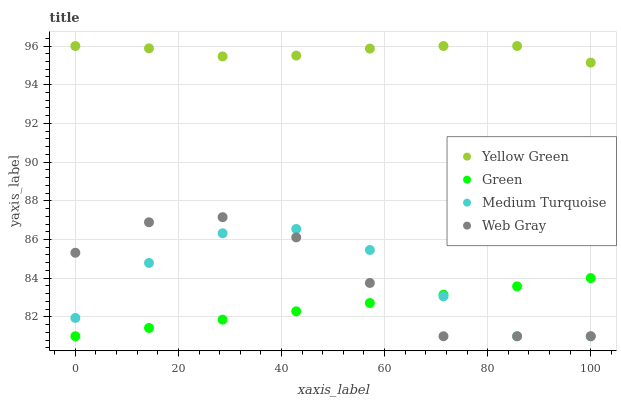Does Green have the minimum area under the curve?
Answer yes or no. Yes. Does Yellow Green have the maximum area under the curve?
Answer yes or no. Yes. Does Yellow Green have the minimum area under the curve?
Answer yes or no. No. Does Green have the maximum area under the curve?
Answer yes or no. No. Is Green the smoothest?
Answer yes or no. Yes. Is Medium Turquoise the roughest?
Answer yes or no. Yes. Is Yellow Green the smoothest?
Answer yes or no. No. Is Yellow Green the roughest?
Answer yes or no. No. Does Web Gray have the lowest value?
Answer yes or no. Yes. Does Yellow Green have the lowest value?
Answer yes or no. No. Does Yellow Green have the highest value?
Answer yes or no. Yes. Does Green have the highest value?
Answer yes or no. No. Is Web Gray less than Yellow Green?
Answer yes or no. Yes. Is Yellow Green greater than Green?
Answer yes or no. Yes. Does Web Gray intersect Medium Turquoise?
Answer yes or no. Yes. Is Web Gray less than Medium Turquoise?
Answer yes or no. No. Is Web Gray greater than Medium Turquoise?
Answer yes or no. No. Does Web Gray intersect Yellow Green?
Answer yes or no. No. 